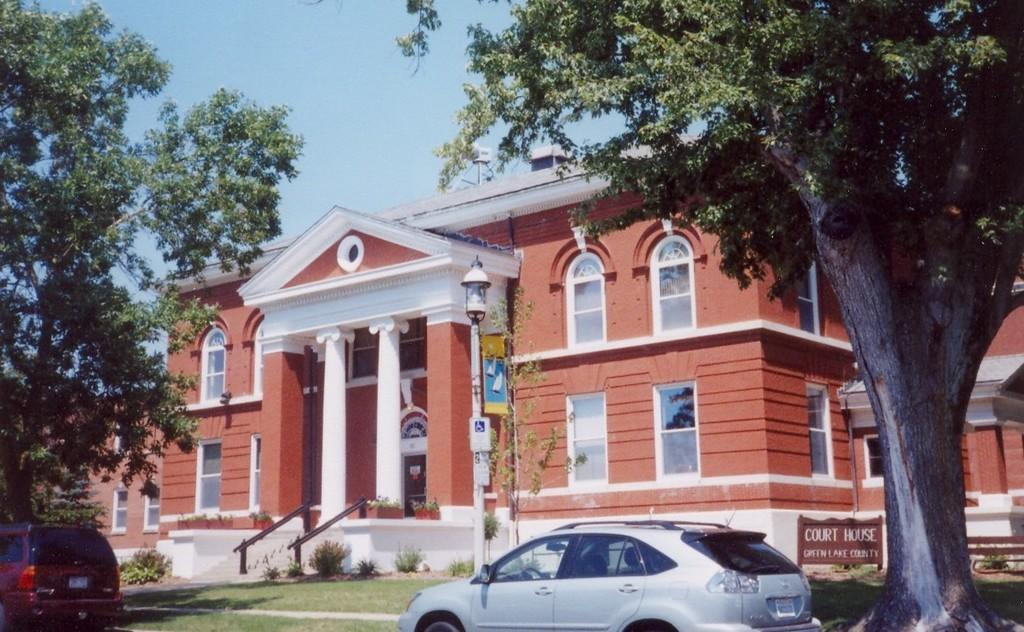What type of vehicles can be seen in the image? There are cars in the image. What type of vegetation is present in the image? There is grass, plants, and trees in the image. What type of structures are present in the image? There are boards, a pole, a light, and a building in the image. What part of the natural environment is visible in the image? The sky is visible in the background of the image. How many arms are visible in the image? There are no arms visible in the image. What type of measurement can be taken using the light in the image? The light in the image is not used for measuring anything. 